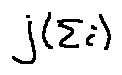Convert formula to latex. <formula><loc_0><loc_0><loc_500><loc_500>j ( \sum i )</formula> 